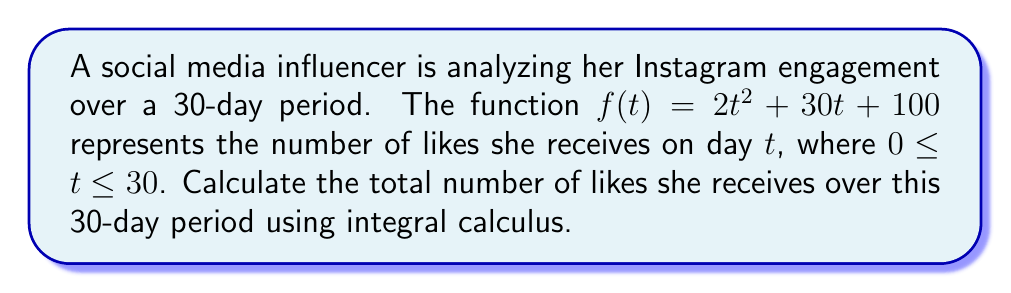Show me your answer to this math problem. To find the total number of likes over the 30-day period, we need to calculate the area under the curve $f(t) = 2t^2 + 30t + 100$ from $t=0$ to $t=30$. This can be done using a definite integral.

Steps:
1) Set up the definite integral:
   $$\int_0^{30} (2t^2 + 30t + 100) dt$$

2) Integrate the function:
   $$\left[ \frac{2t^3}{3} + 15t^2 + 100t \right]_0^{30}$$

3) Evaluate the integral at the upper and lower bounds:
   $$\left(\frac{2(30)^3}{3} + 15(30)^2 + 100(30)\right) - \left(\frac{2(0)^3}{3} + 15(0)^2 + 100(0)\right)$$

4) Simplify:
   $$\left(18000 + 13500 + 3000\right) - (0)$$
   $$= 34500$$

Therefore, the total number of likes over the 30-day period is 34,500.
Answer: 34,500 likes 